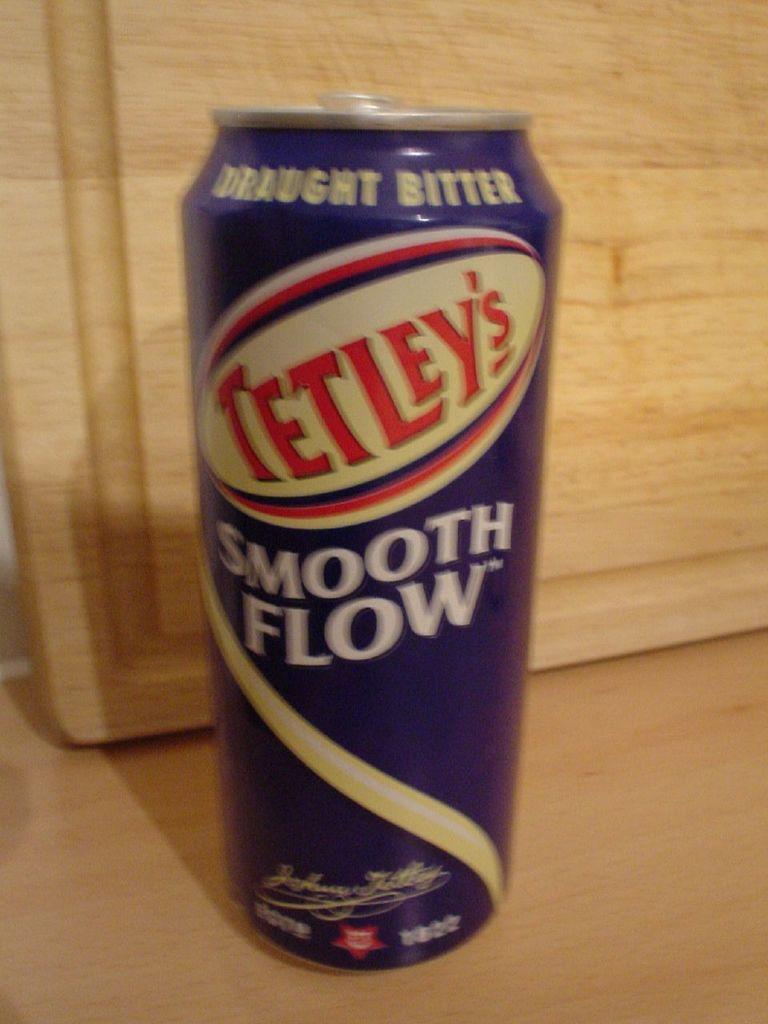What is the brand name here?
Give a very brief answer. Tetley's. The can says what kind of flow?
Make the answer very short. Smooth. 